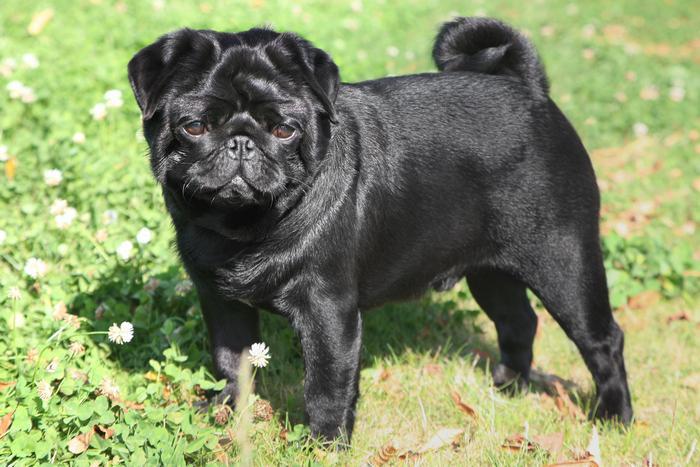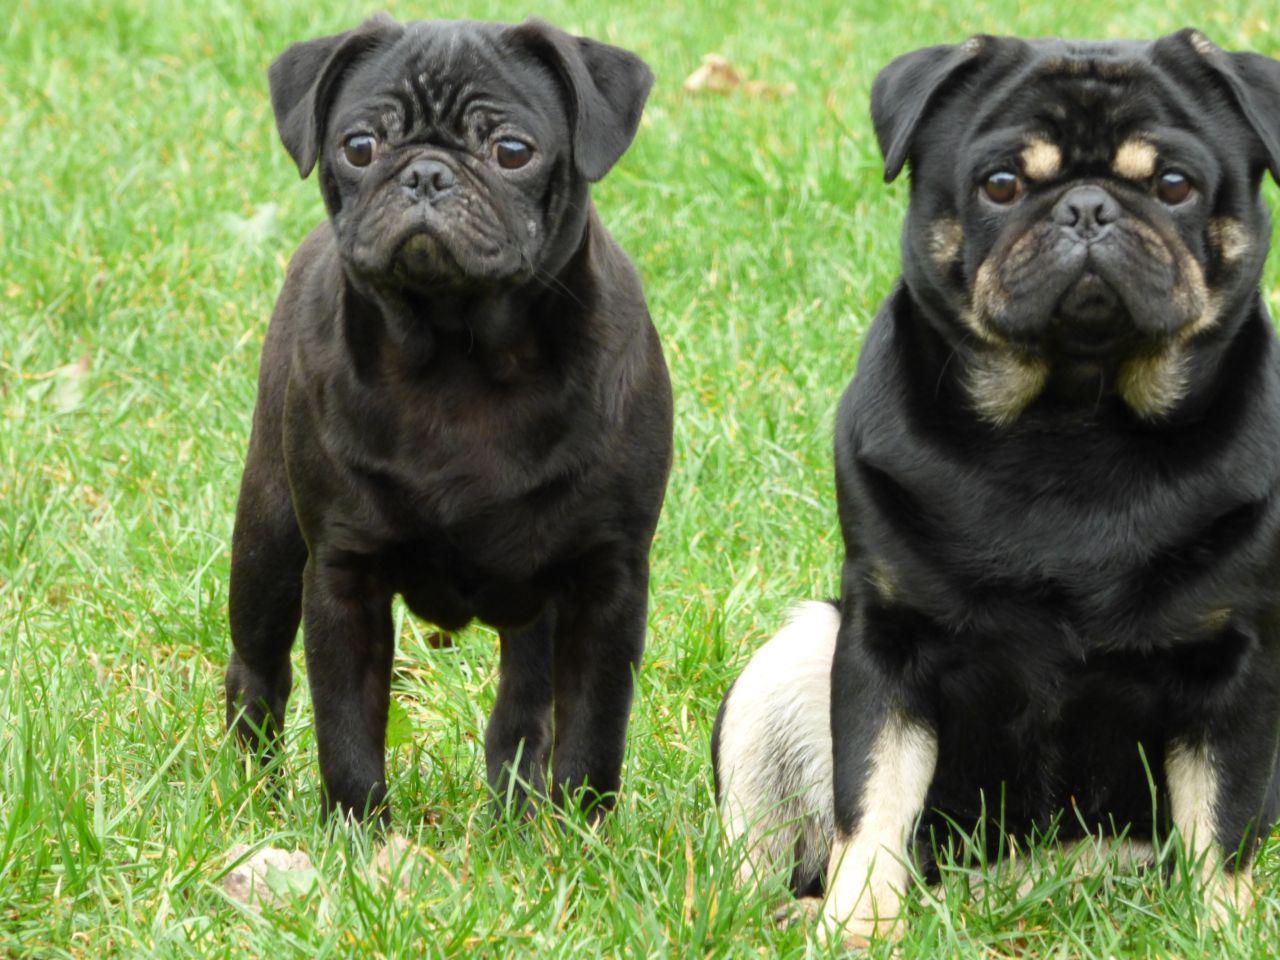The first image is the image on the left, the second image is the image on the right. For the images displayed, is the sentence "We've got three pups here." factually correct? Answer yes or no. Yes. The first image is the image on the left, the second image is the image on the right. Examine the images to the left and right. Is the description "There is a single black dog looking at the camera." accurate? Answer yes or no. Yes. 